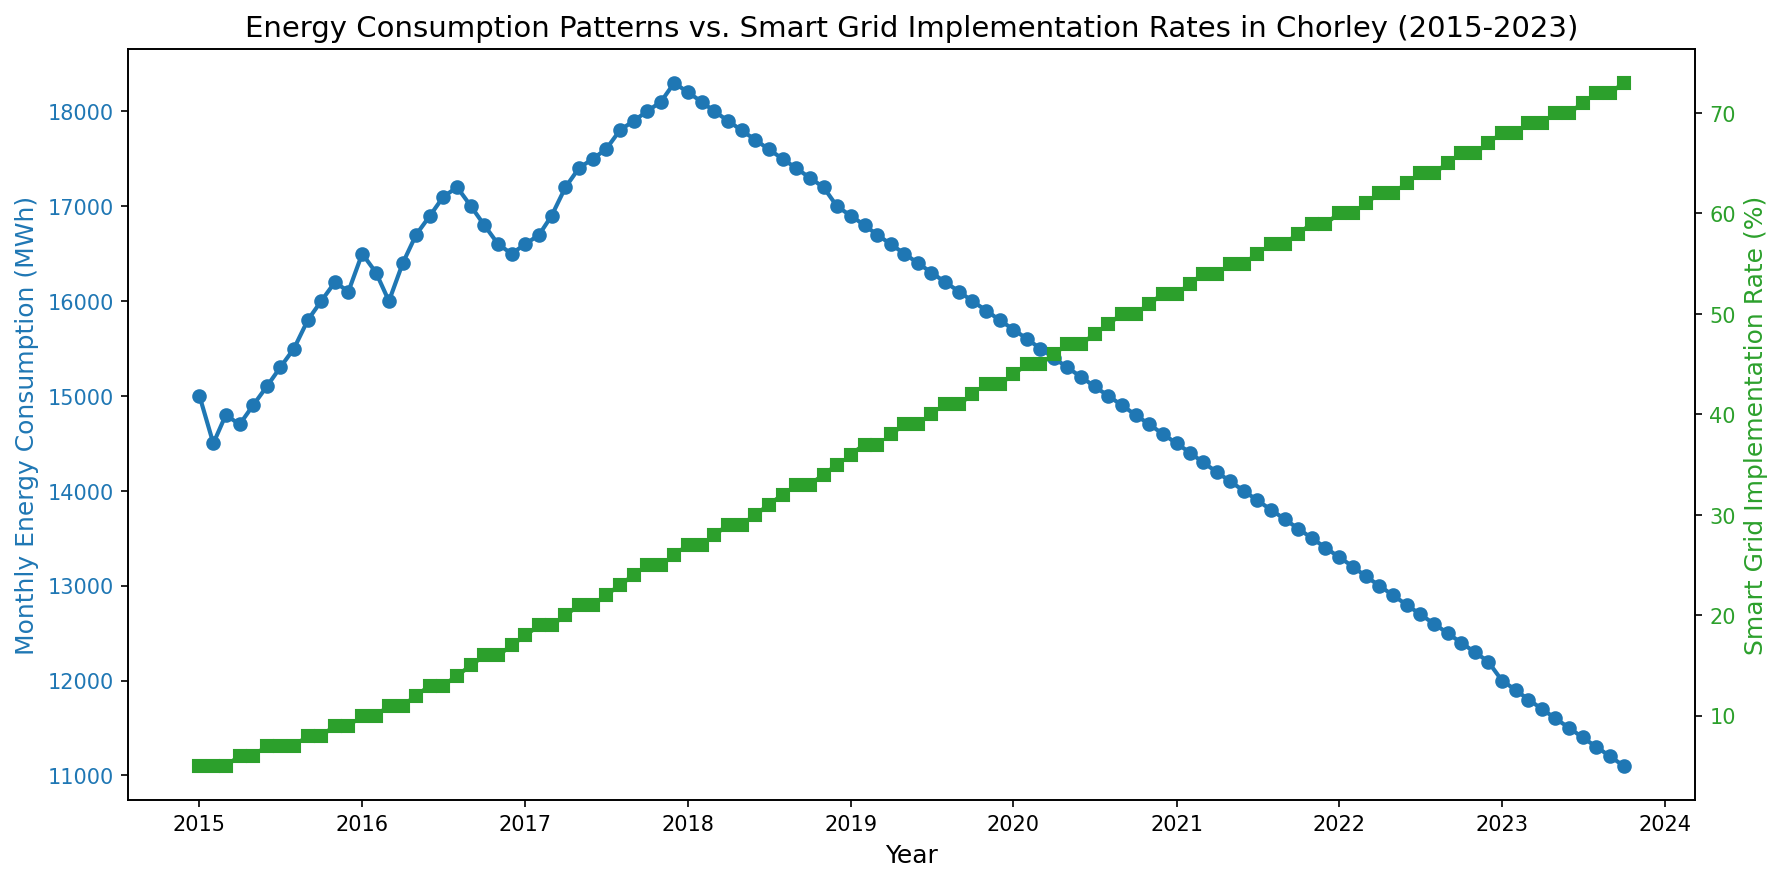What was the monthly energy consumption in the month with the highest smart grid implementation rate? The highest smart grid implementation rate is 73% in October 2023. The corresponding monthly energy consumption in this month is 11,100 MWh.
Answer: 11,100 MWh How did the energy consumption trend change from January 2015 to October 2023? Starting from January 2015, where the energy consumption was 15,000 MWh, there is a rising trend until November 2017 where it peaks at 18,300 MWh, after that it steadily declines to 11,100 MWh by October 2023.
Answer: Rising, then declining Which year had the largest increase in smart grid implementation rate? To find the largest annual increase, observe the year-to-year changes on the secondary (green line) axis. From January 2020 to January 2021, the implementation rate increased from 44% to 52%, the largest annual increase of 8 percentage points.
Answer: 2021 Is there a noticeable correlation between energy consumption and smart grid implementation rate over the years? Over the years, as the smart grid implementation rate (green line) increased, the monthly energy consumption (blue line) showed a general decline after 2017, indicating a negative correlation.
Answer: Negative correlation What is the difference in monthly energy consumption between the peak month and the month with the lowest implementation rate? The peak monthly energy consumption is 18,300 MWh in November 2017, and the lowest implementation rate is 5% in early 2015, with a consumption of 14,500 MWh in February 2015. The difference is 18,300 - 14,500 = 3,800 MWh.
Answer: 3,800 MWh By how much did the energy consumption decrease from the beginning to the end of the period shown? The energy consumption at the beginning of the period (January 2015) was 15,000 MWh, and at the end (October 2023) it was 11,100 MWh. The decrease is 15,000 - 11,100 = 3,900 MWh.
Answer: 3,900 MWh What was the smart grid implementation rate when the monthly energy consumption first fell below 16,000 MWh? The first time the monthly energy consumption fell below 16,000 MWh was in October 2019, with a rate of 42%.
Answer: 42% Which period saw a consistent monthly increase in smart grid implementation rate without any decrease, and what was the change in consumption during this period? From January 2015 to December 2017, the smart grid implementation rate consistently increased from 5% to 26%. During this period, the energy consumption increased from 15,000 MWh to 18,300 MWh, an increase of 3,300 MWh.
Answer: January 2015 to December 2017, +3,300 MWh In which months did the energy consumption and implementation rate intersect, and what were those values? The blue and green lines don't cross each other on the plot, indicating that their values don't intersect.
Answer: Never intersected 